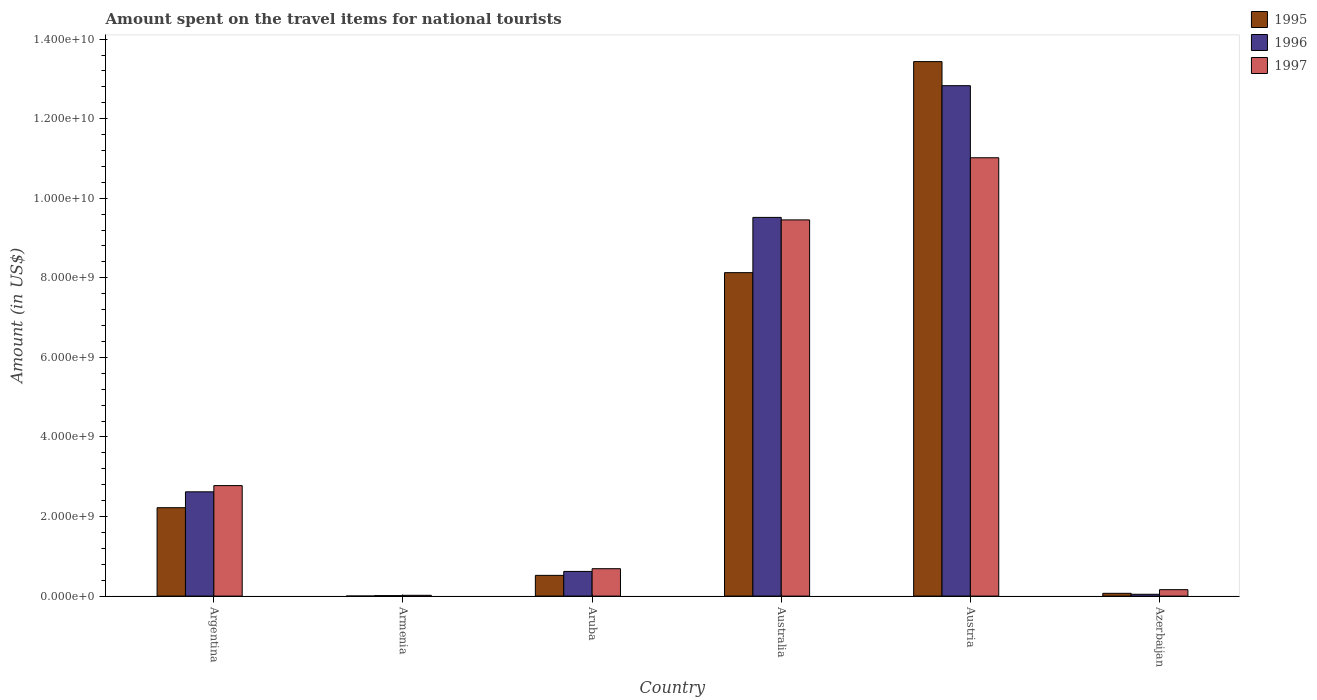Are the number of bars per tick equal to the number of legend labels?
Provide a succinct answer. Yes. How many bars are there on the 2nd tick from the left?
Make the answer very short. 3. How many bars are there on the 2nd tick from the right?
Provide a succinct answer. 3. What is the label of the 3rd group of bars from the left?
Offer a terse response. Aruba. In how many cases, is the number of bars for a given country not equal to the number of legend labels?
Offer a terse response. 0. What is the amount spent on the travel items for national tourists in 1996 in Azerbaijan?
Your answer should be compact. 4.60e+07. Across all countries, what is the maximum amount spent on the travel items for national tourists in 1995?
Provide a short and direct response. 1.34e+1. In which country was the amount spent on the travel items for national tourists in 1997 maximum?
Your response must be concise. Austria. In which country was the amount spent on the travel items for national tourists in 1997 minimum?
Give a very brief answer. Armenia. What is the total amount spent on the travel items for national tourists in 1997 in the graph?
Offer a terse response. 2.41e+1. What is the difference between the amount spent on the travel items for national tourists in 1995 in Argentina and that in Australia?
Offer a terse response. -5.91e+09. What is the difference between the amount spent on the travel items for national tourists in 1995 in Armenia and the amount spent on the travel items for national tourists in 1996 in Azerbaijan?
Your answer should be very brief. -4.50e+07. What is the average amount spent on the travel items for national tourists in 1995 per country?
Your response must be concise. 4.06e+09. What is the difference between the amount spent on the travel items for national tourists of/in 1995 and amount spent on the travel items for national tourists of/in 1996 in Austria?
Your response must be concise. 6.05e+08. In how many countries, is the amount spent on the travel items for national tourists in 1996 greater than 4800000000 US$?
Keep it short and to the point. 2. What is the ratio of the amount spent on the travel items for national tourists in 1997 in Aruba to that in Azerbaijan?
Your answer should be compact. 4.25. Is the difference between the amount spent on the travel items for national tourists in 1995 in Argentina and Armenia greater than the difference between the amount spent on the travel items for national tourists in 1996 in Argentina and Armenia?
Your answer should be very brief. No. What is the difference between the highest and the second highest amount spent on the travel items for national tourists in 1995?
Your answer should be very brief. 1.12e+1. What is the difference between the highest and the lowest amount spent on the travel items for national tourists in 1995?
Provide a short and direct response. 1.34e+1. In how many countries, is the amount spent on the travel items for national tourists in 1996 greater than the average amount spent on the travel items for national tourists in 1996 taken over all countries?
Keep it short and to the point. 2. Is the sum of the amount spent on the travel items for national tourists in 1996 in Armenia and Aruba greater than the maximum amount spent on the travel items for national tourists in 1995 across all countries?
Your answer should be compact. No. What does the 3rd bar from the right in Austria represents?
Ensure brevity in your answer.  1995. How many countries are there in the graph?
Your answer should be compact. 6. What is the difference between two consecutive major ticks on the Y-axis?
Ensure brevity in your answer.  2.00e+09. Are the values on the major ticks of Y-axis written in scientific E-notation?
Offer a very short reply. Yes. Does the graph contain any zero values?
Your answer should be very brief. No. Does the graph contain grids?
Your answer should be compact. No. Where does the legend appear in the graph?
Offer a very short reply. Top right. How many legend labels are there?
Make the answer very short. 3. What is the title of the graph?
Ensure brevity in your answer.  Amount spent on the travel items for national tourists. What is the label or title of the X-axis?
Your answer should be compact. Country. What is the label or title of the Y-axis?
Make the answer very short. Amount (in US$). What is the Amount (in US$) in 1995 in Argentina?
Offer a terse response. 2.22e+09. What is the Amount (in US$) in 1996 in Argentina?
Your response must be concise. 2.62e+09. What is the Amount (in US$) of 1997 in Argentina?
Your answer should be very brief. 2.78e+09. What is the Amount (in US$) of 1995 in Armenia?
Ensure brevity in your answer.  1.00e+06. What is the Amount (in US$) of 1997 in Armenia?
Your answer should be very brief. 2.00e+07. What is the Amount (in US$) of 1995 in Aruba?
Provide a succinct answer. 5.21e+08. What is the Amount (in US$) in 1996 in Aruba?
Keep it short and to the point. 6.20e+08. What is the Amount (in US$) of 1997 in Aruba?
Give a very brief answer. 6.89e+08. What is the Amount (in US$) in 1995 in Australia?
Your answer should be compact. 8.13e+09. What is the Amount (in US$) of 1996 in Australia?
Your answer should be very brief. 9.52e+09. What is the Amount (in US$) in 1997 in Australia?
Your answer should be compact. 9.46e+09. What is the Amount (in US$) of 1995 in Austria?
Your response must be concise. 1.34e+1. What is the Amount (in US$) in 1996 in Austria?
Provide a succinct answer. 1.28e+1. What is the Amount (in US$) of 1997 in Austria?
Make the answer very short. 1.10e+1. What is the Amount (in US$) in 1995 in Azerbaijan?
Provide a short and direct response. 7.00e+07. What is the Amount (in US$) of 1996 in Azerbaijan?
Make the answer very short. 4.60e+07. What is the Amount (in US$) of 1997 in Azerbaijan?
Offer a very short reply. 1.62e+08. Across all countries, what is the maximum Amount (in US$) in 1995?
Make the answer very short. 1.34e+1. Across all countries, what is the maximum Amount (in US$) in 1996?
Your answer should be compact. 1.28e+1. Across all countries, what is the maximum Amount (in US$) in 1997?
Ensure brevity in your answer.  1.10e+1. What is the total Amount (in US$) in 1995 in the graph?
Your response must be concise. 2.44e+1. What is the total Amount (in US$) of 1996 in the graph?
Your response must be concise. 2.56e+1. What is the total Amount (in US$) of 1997 in the graph?
Give a very brief answer. 2.41e+1. What is the difference between the Amount (in US$) of 1995 in Argentina and that in Armenia?
Provide a short and direct response. 2.22e+09. What is the difference between the Amount (in US$) of 1996 in Argentina and that in Armenia?
Your answer should be very brief. 2.61e+09. What is the difference between the Amount (in US$) in 1997 in Argentina and that in Armenia?
Keep it short and to the point. 2.76e+09. What is the difference between the Amount (in US$) in 1995 in Argentina and that in Aruba?
Ensure brevity in your answer.  1.70e+09. What is the difference between the Amount (in US$) in 1996 in Argentina and that in Aruba?
Keep it short and to the point. 2.00e+09. What is the difference between the Amount (in US$) of 1997 in Argentina and that in Aruba?
Ensure brevity in your answer.  2.09e+09. What is the difference between the Amount (in US$) in 1995 in Argentina and that in Australia?
Your response must be concise. -5.91e+09. What is the difference between the Amount (in US$) in 1996 in Argentina and that in Australia?
Offer a terse response. -6.90e+09. What is the difference between the Amount (in US$) in 1997 in Argentina and that in Australia?
Provide a succinct answer. -6.68e+09. What is the difference between the Amount (in US$) in 1995 in Argentina and that in Austria?
Provide a short and direct response. -1.12e+1. What is the difference between the Amount (in US$) of 1996 in Argentina and that in Austria?
Your response must be concise. -1.02e+1. What is the difference between the Amount (in US$) of 1997 in Argentina and that in Austria?
Provide a short and direct response. -8.24e+09. What is the difference between the Amount (in US$) of 1995 in Argentina and that in Azerbaijan?
Provide a succinct answer. 2.15e+09. What is the difference between the Amount (in US$) of 1996 in Argentina and that in Azerbaijan?
Your answer should be compact. 2.58e+09. What is the difference between the Amount (in US$) in 1997 in Argentina and that in Azerbaijan?
Provide a succinct answer. 2.62e+09. What is the difference between the Amount (in US$) in 1995 in Armenia and that in Aruba?
Provide a short and direct response. -5.20e+08. What is the difference between the Amount (in US$) in 1996 in Armenia and that in Aruba?
Give a very brief answer. -6.08e+08. What is the difference between the Amount (in US$) of 1997 in Armenia and that in Aruba?
Ensure brevity in your answer.  -6.69e+08. What is the difference between the Amount (in US$) in 1995 in Armenia and that in Australia?
Your answer should be very brief. -8.13e+09. What is the difference between the Amount (in US$) of 1996 in Armenia and that in Australia?
Ensure brevity in your answer.  -9.51e+09. What is the difference between the Amount (in US$) in 1997 in Armenia and that in Australia?
Give a very brief answer. -9.44e+09. What is the difference between the Amount (in US$) in 1995 in Armenia and that in Austria?
Provide a succinct answer. -1.34e+1. What is the difference between the Amount (in US$) of 1996 in Armenia and that in Austria?
Offer a terse response. -1.28e+1. What is the difference between the Amount (in US$) in 1997 in Armenia and that in Austria?
Your response must be concise. -1.10e+1. What is the difference between the Amount (in US$) in 1995 in Armenia and that in Azerbaijan?
Offer a terse response. -6.90e+07. What is the difference between the Amount (in US$) of 1996 in Armenia and that in Azerbaijan?
Ensure brevity in your answer.  -3.40e+07. What is the difference between the Amount (in US$) of 1997 in Armenia and that in Azerbaijan?
Provide a short and direct response. -1.42e+08. What is the difference between the Amount (in US$) in 1995 in Aruba and that in Australia?
Offer a very short reply. -7.61e+09. What is the difference between the Amount (in US$) of 1996 in Aruba and that in Australia?
Your answer should be very brief. -8.90e+09. What is the difference between the Amount (in US$) in 1997 in Aruba and that in Australia?
Your answer should be compact. -8.77e+09. What is the difference between the Amount (in US$) in 1995 in Aruba and that in Austria?
Your answer should be very brief. -1.29e+1. What is the difference between the Amount (in US$) of 1996 in Aruba and that in Austria?
Offer a terse response. -1.22e+1. What is the difference between the Amount (in US$) of 1997 in Aruba and that in Austria?
Give a very brief answer. -1.03e+1. What is the difference between the Amount (in US$) in 1995 in Aruba and that in Azerbaijan?
Offer a very short reply. 4.51e+08. What is the difference between the Amount (in US$) of 1996 in Aruba and that in Azerbaijan?
Your answer should be compact. 5.74e+08. What is the difference between the Amount (in US$) of 1997 in Aruba and that in Azerbaijan?
Offer a very short reply. 5.27e+08. What is the difference between the Amount (in US$) of 1995 in Australia and that in Austria?
Ensure brevity in your answer.  -5.30e+09. What is the difference between the Amount (in US$) of 1996 in Australia and that in Austria?
Your answer should be very brief. -3.31e+09. What is the difference between the Amount (in US$) of 1997 in Australia and that in Austria?
Make the answer very short. -1.56e+09. What is the difference between the Amount (in US$) of 1995 in Australia and that in Azerbaijan?
Offer a terse response. 8.06e+09. What is the difference between the Amount (in US$) in 1996 in Australia and that in Azerbaijan?
Your answer should be very brief. 9.47e+09. What is the difference between the Amount (in US$) of 1997 in Australia and that in Azerbaijan?
Ensure brevity in your answer.  9.29e+09. What is the difference between the Amount (in US$) of 1995 in Austria and that in Azerbaijan?
Ensure brevity in your answer.  1.34e+1. What is the difference between the Amount (in US$) in 1996 in Austria and that in Azerbaijan?
Ensure brevity in your answer.  1.28e+1. What is the difference between the Amount (in US$) in 1997 in Austria and that in Azerbaijan?
Offer a very short reply. 1.09e+1. What is the difference between the Amount (in US$) of 1995 in Argentina and the Amount (in US$) of 1996 in Armenia?
Ensure brevity in your answer.  2.21e+09. What is the difference between the Amount (in US$) in 1995 in Argentina and the Amount (in US$) in 1997 in Armenia?
Give a very brief answer. 2.20e+09. What is the difference between the Amount (in US$) of 1996 in Argentina and the Amount (in US$) of 1997 in Armenia?
Keep it short and to the point. 2.60e+09. What is the difference between the Amount (in US$) in 1995 in Argentina and the Amount (in US$) in 1996 in Aruba?
Give a very brief answer. 1.60e+09. What is the difference between the Amount (in US$) in 1995 in Argentina and the Amount (in US$) in 1997 in Aruba?
Your answer should be very brief. 1.53e+09. What is the difference between the Amount (in US$) in 1996 in Argentina and the Amount (in US$) in 1997 in Aruba?
Offer a terse response. 1.93e+09. What is the difference between the Amount (in US$) of 1995 in Argentina and the Amount (in US$) of 1996 in Australia?
Provide a short and direct response. -7.30e+09. What is the difference between the Amount (in US$) in 1995 in Argentina and the Amount (in US$) in 1997 in Australia?
Offer a very short reply. -7.23e+09. What is the difference between the Amount (in US$) of 1996 in Argentina and the Amount (in US$) of 1997 in Australia?
Your answer should be compact. -6.84e+09. What is the difference between the Amount (in US$) of 1995 in Argentina and the Amount (in US$) of 1996 in Austria?
Give a very brief answer. -1.06e+1. What is the difference between the Amount (in US$) in 1995 in Argentina and the Amount (in US$) in 1997 in Austria?
Provide a succinct answer. -8.80e+09. What is the difference between the Amount (in US$) of 1996 in Argentina and the Amount (in US$) of 1997 in Austria?
Make the answer very short. -8.40e+09. What is the difference between the Amount (in US$) in 1995 in Argentina and the Amount (in US$) in 1996 in Azerbaijan?
Ensure brevity in your answer.  2.18e+09. What is the difference between the Amount (in US$) of 1995 in Argentina and the Amount (in US$) of 1997 in Azerbaijan?
Your response must be concise. 2.06e+09. What is the difference between the Amount (in US$) in 1996 in Argentina and the Amount (in US$) in 1997 in Azerbaijan?
Provide a succinct answer. 2.46e+09. What is the difference between the Amount (in US$) in 1995 in Armenia and the Amount (in US$) in 1996 in Aruba?
Provide a succinct answer. -6.19e+08. What is the difference between the Amount (in US$) in 1995 in Armenia and the Amount (in US$) in 1997 in Aruba?
Your answer should be compact. -6.88e+08. What is the difference between the Amount (in US$) of 1996 in Armenia and the Amount (in US$) of 1997 in Aruba?
Your response must be concise. -6.77e+08. What is the difference between the Amount (in US$) of 1995 in Armenia and the Amount (in US$) of 1996 in Australia?
Your answer should be very brief. -9.52e+09. What is the difference between the Amount (in US$) of 1995 in Armenia and the Amount (in US$) of 1997 in Australia?
Give a very brief answer. -9.46e+09. What is the difference between the Amount (in US$) in 1996 in Armenia and the Amount (in US$) in 1997 in Australia?
Offer a very short reply. -9.44e+09. What is the difference between the Amount (in US$) in 1995 in Armenia and the Amount (in US$) in 1996 in Austria?
Keep it short and to the point. -1.28e+1. What is the difference between the Amount (in US$) of 1995 in Armenia and the Amount (in US$) of 1997 in Austria?
Give a very brief answer. -1.10e+1. What is the difference between the Amount (in US$) in 1996 in Armenia and the Amount (in US$) in 1997 in Austria?
Offer a terse response. -1.10e+1. What is the difference between the Amount (in US$) of 1995 in Armenia and the Amount (in US$) of 1996 in Azerbaijan?
Provide a short and direct response. -4.50e+07. What is the difference between the Amount (in US$) in 1995 in Armenia and the Amount (in US$) in 1997 in Azerbaijan?
Your response must be concise. -1.61e+08. What is the difference between the Amount (in US$) in 1996 in Armenia and the Amount (in US$) in 1997 in Azerbaijan?
Give a very brief answer. -1.50e+08. What is the difference between the Amount (in US$) of 1995 in Aruba and the Amount (in US$) of 1996 in Australia?
Keep it short and to the point. -9.00e+09. What is the difference between the Amount (in US$) of 1995 in Aruba and the Amount (in US$) of 1997 in Australia?
Provide a short and direct response. -8.94e+09. What is the difference between the Amount (in US$) in 1996 in Aruba and the Amount (in US$) in 1997 in Australia?
Provide a succinct answer. -8.84e+09. What is the difference between the Amount (in US$) in 1995 in Aruba and the Amount (in US$) in 1996 in Austria?
Keep it short and to the point. -1.23e+1. What is the difference between the Amount (in US$) of 1995 in Aruba and the Amount (in US$) of 1997 in Austria?
Your answer should be compact. -1.05e+1. What is the difference between the Amount (in US$) in 1996 in Aruba and the Amount (in US$) in 1997 in Austria?
Your answer should be compact. -1.04e+1. What is the difference between the Amount (in US$) of 1995 in Aruba and the Amount (in US$) of 1996 in Azerbaijan?
Keep it short and to the point. 4.75e+08. What is the difference between the Amount (in US$) in 1995 in Aruba and the Amount (in US$) in 1997 in Azerbaijan?
Provide a short and direct response. 3.59e+08. What is the difference between the Amount (in US$) in 1996 in Aruba and the Amount (in US$) in 1997 in Azerbaijan?
Keep it short and to the point. 4.58e+08. What is the difference between the Amount (in US$) in 1995 in Australia and the Amount (in US$) in 1996 in Austria?
Your answer should be very brief. -4.70e+09. What is the difference between the Amount (in US$) of 1995 in Australia and the Amount (in US$) of 1997 in Austria?
Provide a succinct answer. -2.89e+09. What is the difference between the Amount (in US$) of 1996 in Australia and the Amount (in US$) of 1997 in Austria?
Make the answer very short. -1.50e+09. What is the difference between the Amount (in US$) in 1995 in Australia and the Amount (in US$) in 1996 in Azerbaijan?
Offer a very short reply. 8.08e+09. What is the difference between the Amount (in US$) in 1995 in Australia and the Amount (in US$) in 1997 in Azerbaijan?
Ensure brevity in your answer.  7.97e+09. What is the difference between the Amount (in US$) of 1996 in Australia and the Amount (in US$) of 1997 in Azerbaijan?
Ensure brevity in your answer.  9.36e+09. What is the difference between the Amount (in US$) in 1995 in Austria and the Amount (in US$) in 1996 in Azerbaijan?
Give a very brief answer. 1.34e+1. What is the difference between the Amount (in US$) in 1995 in Austria and the Amount (in US$) in 1997 in Azerbaijan?
Offer a terse response. 1.33e+1. What is the difference between the Amount (in US$) of 1996 in Austria and the Amount (in US$) of 1997 in Azerbaijan?
Give a very brief answer. 1.27e+1. What is the average Amount (in US$) of 1995 per country?
Make the answer very short. 4.06e+09. What is the average Amount (in US$) in 1996 per country?
Provide a succinct answer. 4.27e+09. What is the average Amount (in US$) in 1997 per country?
Offer a terse response. 4.02e+09. What is the difference between the Amount (in US$) in 1995 and Amount (in US$) in 1996 in Argentina?
Provide a succinct answer. -3.99e+08. What is the difference between the Amount (in US$) in 1995 and Amount (in US$) in 1997 in Argentina?
Give a very brief answer. -5.56e+08. What is the difference between the Amount (in US$) of 1996 and Amount (in US$) of 1997 in Argentina?
Give a very brief answer. -1.57e+08. What is the difference between the Amount (in US$) in 1995 and Amount (in US$) in 1996 in Armenia?
Your response must be concise. -1.10e+07. What is the difference between the Amount (in US$) of 1995 and Amount (in US$) of 1997 in Armenia?
Your response must be concise. -1.90e+07. What is the difference between the Amount (in US$) in 1996 and Amount (in US$) in 1997 in Armenia?
Give a very brief answer. -8.00e+06. What is the difference between the Amount (in US$) of 1995 and Amount (in US$) of 1996 in Aruba?
Offer a terse response. -9.90e+07. What is the difference between the Amount (in US$) in 1995 and Amount (in US$) in 1997 in Aruba?
Provide a succinct answer. -1.68e+08. What is the difference between the Amount (in US$) in 1996 and Amount (in US$) in 1997 in Aruba?
Your answer should be compact. -6.90e+07. What is the difference between the Amount (in US$) in 1995 and Amount (in US$) in 1996 in Australia?
Offer a terse response. -1.39e+09. What is the difference between the Amount (in US$) of 1995 and Amount (in US$) of 1997 in Australia?
Your answer should be compact. -1.33e+09. What is the difference between the Amount (in US$) of 1996 and Amount (in US$) of 1997 in Australia?
Ensure brevity in your answer.  6.30e+07. What is the difference between the Amount (in US$) in 1995 and Amount (in US$) in 1996 in Austria?
Your response must be concise. 6.05e+08. What is the difference between the Amount (in US$) of 1995 and Amount (in US$) of 1997 in Austria?
Offer a very short reply. 2.42e+09. What is the difference between the Amount (in US$) in 1996 and Amount (in US$) in 1997 in Austria?
Give a very brief answer. 1.81e+09. What is the difference between the Amount (in US$) in 1995 and Amount (in US$) in 1996 in Azerbaijan?
Give a very brief answer. 2.40e+07. What is the difference between the Amount (in US$) in 1995 and Amount (in US$) in 1997 in Azerbaijan?
Offer a very short reply. -9.20e+07. What is the difference between the Amount (in US$) in 1996 and Amount (in US$) in 1997 in Azerbaijan?
Provide a succinct answer. -1.16e+08. What is the ratio of the Amount (in US$) in 1995 in Argentina to that in Armenia?
Offer a terse response. 2222. What is the ratio of the Amount (in US$) in 1996 in Argentina to that in Armenia?
Your answer should be compact. 218.42. What is the ratio of the Amount (in US$) in 1997 in Argentina to that in Armenia?
Ensure brevity in your answer.  138.9. What is the ratio of the Amount (in US$) in 1995 in Argentina to that in Aruba?
Provide a short and direct response. 4.26. What is the ratio of the Amount (in US$) of 1996 in Argentina to that in Aruba?
Provide a short and direct response. 4.23. What is the ratio of the Amount (in US$) of 1997 in Argentina to that in Aruba?
Provide a succinct answer. 4.03. What is the ratio of the Amount (in US$) in 1995 in Argentina to that in Australia?
Offer a terse response. 0.27. What is the ratio of the Amount (in US$) in 1996 in Argentina to that in Australia?
Offer a very short reply. 0.28. What is the ratio of the Amount (in US$) in 1997 in Argentina to that in Australia?
Your answer should be very brief. 0.29. What is the ratio of the Amount (in US$) of 1995 in Argentina to that in Austria?
Make the answer very short. 0.17. What is the ratio of the Amount (in US$) in 1996 in Argentina to that in Austria?
Your answer should be compact. 0.2. What is the ratio of the Amount (in US$) of 1997 in Argentina to that in Austria?
Offer a terse response. 0.25. What is the ratio of the Amount (in US$) of 1995 in Argentina to that in Azerbaijan?
Offer a very short reply. 31.74. What is the ratio of the Amount (in US$) in 1996 in Argentina to that in Azerbaijan?
Keep it short and to the point. 56.98. What is the ratio of the Amount (in US$) of 1997 in Argentina to that in Azerbaijan?
Your answer should be compact. 17.15. What is the ratio of the Amount (in US$) of 1995 in Armenia to that in Aruba?
Keep it short and to the point. 0. What is the ratio of the Amount (in US$) of 1996 in Armenia to that in Aruba?
Give a very brief answer. 0.02. What is the ratio of the Amount (in US$) of 1997 in Armenia to that in Aruba?
Make the answer very short. 0.03. What is the ratio of the Amount (in US$) in 1996 in Armenia to that in Australia?
Offer a terse response. 0. What is the ratio of the Amount (in US$) in 1997 in Armenia to that in Australia?
Provide a short and direct response. 0. What is the ratio of the Amount (in US$) of 1995 in Armenia to that in Austria?
Ensure brevity in your answer.  0. What is the ratio of the Amount (in US$) of 1996 in Armenia to that in Austria?
Your answer should be very brief. 0. What is the ratio of the Amount (in US$) in 1997 in Armenia to that in Austria?
Ensure brevity in your answer.  0. What is the ratio of the Amount (in US$) in 1995 in Armenia to that in Azerbaijan?
Offer a very short reply. 0.01. What is the ratio of the Amount (in US$) in 1996 in Armenia to that in Azerbaijan?
Your answer should be very brief. 0.26. What is the ratio of the Amount (in US$) in 1997 in Armenia to that in Azerbaijan?
Your response must be concise. 0.12. What is the ratio of the Amount (in US$) in 1995 in Aruba to that in Australia?
Offer a terse response. 0.06. What is the ratio of the Amount (in US$) in 1996 in Aruba to that in Australia?
Keep it short and to the point. 0.07. What is the ratio of the Amount (in US$) in 1997 in Aruba to that in Australia?
Keep it short and to the point. 0.07. What is the ratio of the Amount (in US$) of 1995 in Aruba to that in Austria?
Give a very brief answer. 0.04. What is the ratio of the Amount (in US$) of 1996 in Aruba to that in Austria?
Provide a succinct answer. 0.05. What is the ratio of the Amount (in US$) in 1997 in Aruba to that in Austria?
Your answer should be very brief. 0.06. What is the ratio of the Amount (in US$) of 1995 in Aruba to that in Azerbaijan?
Make the answer very short. 7.44. What is the ratio of the Amount (in US$) in 1996 in Aruba to that in Azerbaijan?
Provide a short and direct response. 13.48. What is the ratio of the Amount (in US$) in 1997 in Aruba to that in Azerbaijan?
Your response must be concise. 4.25. What is the ratio of the Amount (in US$) of 1995 in Australia to that in Austria?
Offer a terse response. 0.61. What is the ratio of the Amount (in US$) in 1996 in Australia to that in Austria?
Offer a terse response. 0.74. What is the ratio of the Amount (in US$) of 1997 in Australia to that in Austria?
Your response must be concise. 0.86. What is the ratio of the Amount (in US$) in 1995 in Australia to that in Azerbaijan?
Give a very brief answer. 116.14. What is the ratio of the Amount (in US$) of 1996 in Australia to that in Azerbaijan?
Offer a terse response. 206.93. What is the ratio of the Amount (in US$) in 1997 in Australia to that in Azerbaijan?
Keep it short and to the point. 58.37. What is the ratio of the Amount (in US$) of 1995 in Austria to that in Azerbaijan?
Make the answer very short. 191.93. What is the ratio of the Amount (in US$) in 1996 in Austria to that in Azerbaijan?
Your response must be concise. 278.91. What is the ratio of the Amount (in US$) of 1997 in Austria to that in Azerbaijan?
Provide a succinct answer. 68.01. What is the difference between the highest and the second highest Amount (in US$) in 1995?
Offer a terse response. 5.30e+09. What is the difference between the highest and the second highest Amount (in US$) of 1996?
Your answer should be compact. 3.31e+09. What is the difference between the highest and the second highest Amount (in US$) of 1997?
Your answer should be very brief. 1.56e+09. What is the difference between the highest and the lowest Amount (in US$) of 1995?
Make the answer very short. 1.34e+1. What is the difference between the highest and the lowest Amount (in US$) of 1996?
Offer a very short reply. 1.28e+1. What is the difference between the highest and the lowest Amount (in US$) of 1997?
Offer a terse response. 1.10e+1. 